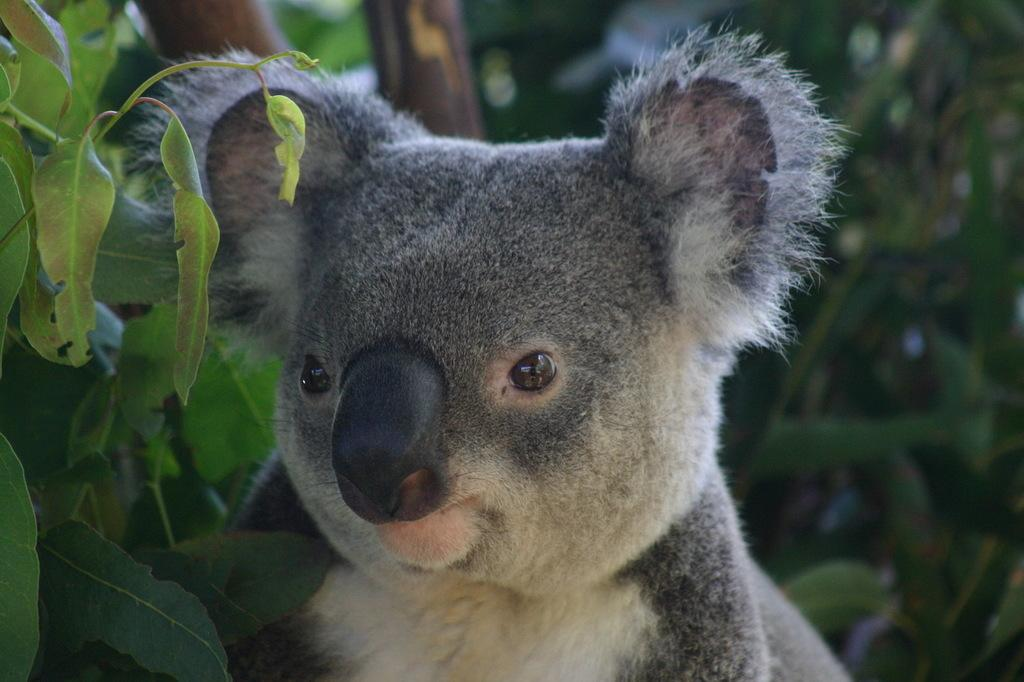What is the main subject in the center of the image? There is an animal in the center of the image. What can be seen in the background of the image? There are trees in the background of the image. What type of curve can be seen on the animal's wrist in the image? There is no curve or wrist visible on the animal in the image, as it is not a human or a creature with a wrist. 